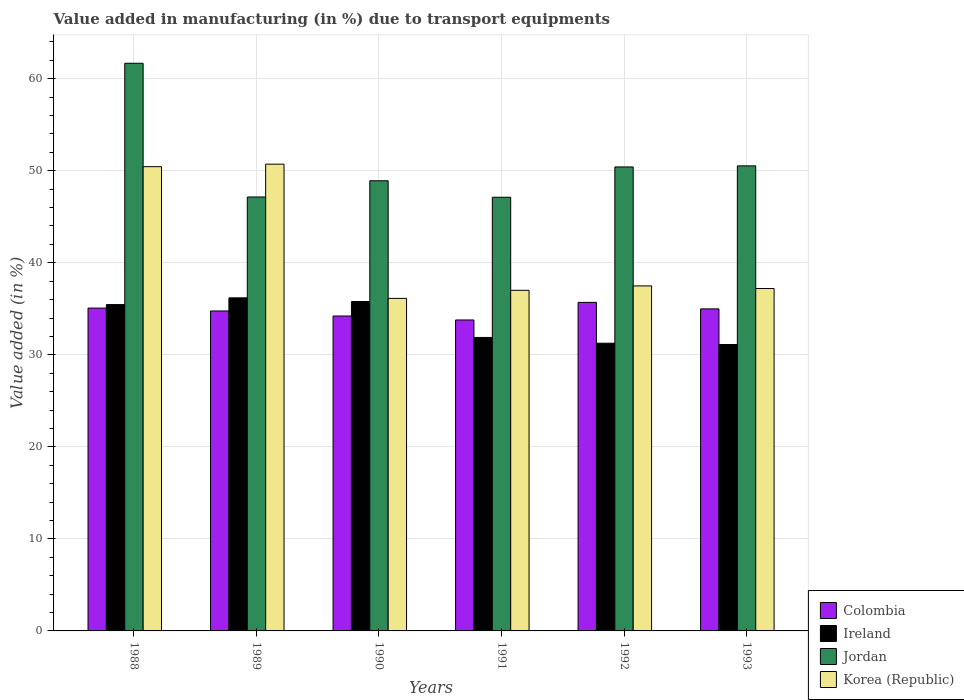How many groups of bars are there?
Provide a succinct answer. 6. Are the number of bars per tick equal to the number of legend labels?
Offer a terse response. Yes. How many bars are there on the 5th tick from the right?
Give a very brief answer. 4. What is the percentage of value added in manufacturing due to transport equipments in Ireland in 1988?
Keep it short and to the point. 35.46. Across all years, what is the maximum percentage of value added in manufacturing due to transport equipments in Korea (Republic)?
Your answer should be compact. 50.72. Across all years, what is the minimum percentage of value added in manufacturing due to transport equipments in Korea (Republic)?
Offer a very short reply. 36.13. In which year was the percentage of value added in manufacturing due to transport equipments in Jordan maximum?
Ensure brevity in your answer.  1988. What is the total percentage of value added in manufacturing due to transport equipments in Jordan in the graph?
Offer a terse response. 305.82. What is the difference between the percentage of value added in manufacturing due to transport equipments in Ireland in 1989 and that in 1991?
Give a very brief answer. 4.3. What is the difference between the percentage of value added in manufacturing due to transport equipments in Korea (Republic) in 1988 and the percentage of value added in manufacturing due to transport equipments in Jordan in 1989?
Provide a short and direct response. 3.29. What is the average percentage of value added in manufacturing due to transport equipments in Jordan per year?
Provide a short and direct response. 50.97. In the year 1991, what is the difference between the percentage of value added in manufacturing due to transport equipments in Jordan and percentage of value added in manufacturing due to transport equipments in Ireland?
Your response must be concise. 15.24. What is the ratio of the percentage of value added in manufacturing due to transport equipments in Colombia in 1988 to that in 1991?
Offer a very short reply. 1.04. Is the difference between the percentage of value added in manufacturing due to transport equipments in Jordan in 1992 and 1993 greater than the difference between the percentage of value added in manufacturing due to transport equipments in Ireland in 1992 and 1993?
Give a very brief answer. No. What is the difference between the highest and the second highest percentage of value added in manufacturing due to transport equipments in Jordan?
Ensure brevity in your answer.  11.15. What is the difference between the highest and the lowest percentage of value added in manufacturing due to transport equipments in Korea (Republic)?
Your response must be concise. 14.59. Is the sum of the percentage of value added in manufacturing due to transport equipments in Korea (Republic) in 1988 and 1991 greater than the maximum percentage of value added in manufacturing due to transport equipments in Jordan across all years?
Keep it short and to the point. Yes. Is it the case that in every year, the sum of the percentage of value added in manufacturing due to transport equipments in Korea (Republic) and percentage of value added in manufacturing due to transport equipments in Ireland is greater than the sum of percentage of value added in manufacturing due to transport equipments in Colombia and percentage of value added in manufacturing due to transport equipments in Jordan?
Your answer should be compact. Yes. What does the 4th bar from the right in 1991 represents?
Offer a very short reply. Colombia. Is it the case that in every year, the sum of the percentage of value added in manufacturing due to transport equipments in Korea (Republic) and percentage of value added in manufacturing due to transport equipments in Ireland is greater than the percentage of value added in manufacturing due to transport equipments in Colombia?
Make the answer very short. Yes. Are all the bars in the graph horizontal?
Provide a short and direct response. No. Are the values on the major ticks of Y-axis written in scientific E-notation?
Provide a succinct answer. No. How many legend labels are there?
Provide a short and direct response. 4. How are the legend labels stacked?
Provide a short and direct response. Vertical. What is the title of the graph?
Your answer should be very brief. Value added in manufacturing (in %) due to transport equipments. Does "Ghana" appear as one of the legend labels in the graph?
Offer a very short reply. No. What is the label or title of the Y-axis?
Give a very brief answer. Value added (in %). What is the Value added (in %) in Colombia in 1988?
Keep it short and to the point. 35.08. What is the Value added (in %) of Ireland in 1988?
Keep it short and to the point. 35.46. What is the Value added (in %) in Jordan in 1988?
Your answer should be compact. 61.68. What is the Value added (in %) of Korea (Republic) in 1988?
Your response must be concise. 50.45. What is the Value added (in %) in Colombia in 1989?
Give a very brief answer. 34.77. What is the Value added (in %) in Ireland in 1989?
Offer a very short reply. 36.19. What is the Value added (in %) of Jordan in 1989?
Provide a short and direct response. 47.15. What is the Value added (in %) in Korea (Republic) in 1989?
Your response must be concise. 50.72. What is the Value added (in %) in Colombia in 1990?
Make the answer very short. 34.22. What is the Value added (in %) of Ireland in 1990?
Your response must be concise. 35.79. What is the Value added (in %) of Jordan in 1990?
Your response must be concise. 48.91. What is the Value added (in %) in Korea (Republic) in 1990?
Provide a short and direct response. 36.13. What is the Value added (in %) in Colombia in 1991?
Provide a succinct answer. 33.79. What is the Value added (in %) in Ireland in 1991?
Your response must be concise. 31.89. What is the Value added (in %) in Jordan in 1991?
Your response must be concise. 47.12. What is the Value added (in %) in Korea (Republic) in 1991?
Offer a terse response. 37.01. What is the Value added (in %) in Colombia in 1992?
Your answer should be very brief. 35.7. What is the Value added (in %) in Ireland in 1992?
Make the answer very short. 31.26. What is the Value added (in %) of Jordan in 1992?
Offer a terse response. 50.42. What is the Value added (in %) of Korea (Republic) in 1992?
Keep it short and to the point. 37.49. What is the Value added (in %) in Colombia in 1993?
Give a very brief answer. 34.99. What is the Value added (in %) of Ireland in 1993?
Your answer should be very brief. 31.12. What is the Value added (in %) in Jordan in 1993?
Your answer should be very brief. 50.53. What is the Value added (in %) of Korea (Republic) in 1993?
Offer a terse response. 37.21. Across all years, what is the maximum Value added (in %) of Colombia?
Ensure brevity in your answer.  35.7. Across all years, what is the maximum Value added (in %) of Ireland?
Make the answer very short. 36.19. Across all years, what is the maximum Value added (in %) of Jordan?
Give a very brief answer. 61.68. Across all years, what is the maximum Value added (in %) of Korea (Republic)?
Your answer should be very brief. 50.72. Across all years, what is the minimum Value added (in %) in Colombia?
Your response must be concise. 33.79. Across all years, what is the minimum Value added (in %) of Ireland?
Give a very brief answer. 31.12. Across all years, what is the minimum Value added (in %) in Jordan?
Make the answer very short. 47.12. Across all years, what is the minimum Value added (in %) of Korea (Republic)?
Your answer should be very brief. 36.13. What is the total Value added (in %) of Colombia in the graph?
Offer a terse response. 208.54. What is the total Value added (in %) in Ireland in the graph?
Your response must be concise. 201.72. What is the total Value added (in %) in Jordan in the graph?
Give a very brief answer. 305.82. What is the total Value added (in %) of Korea (Republic) in the graph?
Your answer should be compact. 249. What is the difference between the Value added (in %) in Colombia in 1988 and that in 1989?
Ensure brevity in your answer.  0.31. What is the difference between the Value added (in %) in Ireland in 1988 and that in 1989?
Your answer should be very brief. -0.73. What is the difference between the Value added (in %) of Jordan in 1988 and that in 1989?
Ensure brevity in your answer.  14.53. What is the difference between the Value added (in %) in Korea (Republic) in 1988 and that in 1989?
Make the answer very short. -0.27. What is the difference between the Value added (in %) of Colombia in 1988 and that in 1990?
Offer a terse response. 0.86. What is the difference between the Value added (in %) of Ireland in 1988 and that in 1990?
Ensure brevity in your answer.  -0.33. What is the difference between the Value added (in %) of Jordan in 1988 and that in 1990?
Your response must be concise. 12.77. What is the difference between the Value added (in %) in Korea (Republic) in 1988 and that in 1990?
Keep it short and to the point. 14.31. What is the difference between the Value added (in %) in Colombia in 1988 and that in 1991?
Offer a very short reply. 1.29. What is the difference between the Value added (in %) in Ireland in 1988 and that in 1991?
Provide a succinct answer. 3.57. What is the difference between the Value added (in %) in Jordan in 1988 and that in 1991?
Give a very brief answer. 14.56. What is the difference between the Value added (in %) of Korea (Republic) in 1988 and that in 1991?
Offer a very short reply. 13.43. What is the difference between the Value added (in %) of Colombia in 1988 and that in 1992?
Your answer should be compact. -0.62. What is the difference between the Value added (in %) in Ireland in 1988 and that in 1992?
Ensure brevity in your answer.  4.2. What is the difference between the Value added (in %) in Jordan in 1988 and that in 1992?
Ensure brevity in your answer.  11.27. What is the difference between the Value added (in %) in Korea (Republic) in 1988 and that in 1992?
Your answer should be very brief. 12.96. What is the difference between the Value added (in %) in Colombia in 1988 and that in 1993?
Ensure brevity in your answer.  0.09. What is the difference between the Value added (in %) in Ireland in 1988 and that in 1993?
Provide a short and direct response. 4.34. What is the difference between the Value added (in %) in Jordan in 1988 and that in 1993?
Make the answer very short. 11.15. What is the difference between the Value added (in %) of Korea (Republic) in 1988 and that in 1993?
Provide a succinct answer. 13.24. What is the difference between the Value added (in %) of Colombia in 1989 and that in 1990?
Give a very brief answer. 0.55. What is the difference between the Value added (in %) of Ireland in 1989 and that in 1990?
Make the answer very short. 0.4. What is the difference between the Value added (in %) of Jordan in 1989 and that in 1990?
Your answer should be compact. -1.76. What is the difference between the Value added (in %) in Korea (Republic) in 1989 and that in 1990?
Offer a terse response. 14.59. What is the difference between the Value added (in %) of Colombia in 1989 and that in 1991?
Offer a terse response. 0.98. What is the difference between the Value added (in %) in Ireland in 1989 and that in 1991?
Provide a succinct answer. 4.3. What is the difference between the Value added (in %) in Jordan in 1989 and that in 1991?
Ensure brevity in your answer.  0.03. What is the difference between the Value added (in %) in Korea (Republic) in 1989 and that in 1991?
Keep it short and to the point. 13.71. What is the difference between the Value added (in %) in Colombia in 1989 and that in 1992?
Offer a terse response. -0.93. What is the difference between the Value added (in %) in Ireland in 1989 and that in 1992?
Provide a short and direct response. 4.93. What is the difference between the Value added (in %) of Jordan in 1989 and that in 1992?
Your answer should be compact. -3.26. What is the difference between the Value added (in %) of Korea (Republic) in 1989 and that in 1992?
Offer a very short reply. 13.23. What is the difference between the Value added (in %) of Colombia in 1989 and that in 1993?
Ensure brevity in your answer.  -0.23. What is the difference between the Value added (in %) in Ireland in 1989 and that in 1993?
Make the answer very short. 5.07. What is the difference between the Value added (in %) of Jordan in 1989 and that in 1993?
Give a very brief answer. -3.38. What is the difference between the Value added (in %) in Korea (Republic) in 1989 and that in 1993?
Your response must be concise. 13.51. What is the difference between the Value added (in %) of Colombia in 1990 and that in 1991?
Your answer should be very brief. 0.43. What is the difference between the Value added (in %) in Ireland in 1990 and that in 1991?
Provide a short and direct response. 3.9. What is the difference between the Value added (in %) in Jordan in 1990 and that in 1991?
Your response must be concise. 1.79. What is the difference between the Value added (in %) of Korea (Republic) in 1990 and that in 1991?
Provide a succinct answer. -0.88. What is the difference between the Value added (in %) of Colombia in 1990 and that in 1992?
Make the answer very short. -1.48. What is the difference between the Value added (in %) in Ireland in 1990 and that in 1992?
Your answer should be compact. 4.53. What is the difference between the Value added (in %) in Jordan in 1990 and that in 1992?
Provide a short and direct response. -1.5. What is the difference between the Value added (in %) in Korea (Republic) in 1990 and that in 1992?
Your response must be concise. -1.35. What is the difference between the Value added (in %) in Colombia in 1990 and that in 1993?
Ensure brevity in your answer.  -0.77. What is the difference between the Value added (in %) in Ireland in 1990 and that in 1993?
Offer a very short reply. 4.67. What is the difference between the Value added (in %) of Jordan in 1990 and that in 1993?
Provide a short and direct response. -1.62. What is the difference between the Value added (in %) in Korea (Republic) in 1990 and that in 1993?
Provide a short and direct response. -1.07. What is the difference between the Value added (in %) in Colombia in 1991 and that in 1992?
Provide a short and direct response. -1.91. What is the difference between the Value added (in %) in Ireland in 1991 and that in 1992?
Make the answer very short. 0.62. What is the difference between the Value added (in %) of Jordan in 1991 and that in 1992?
Your response must be concise. -3.29. What is the difference between the Value added (in %) of Korea (Republic) in 1991 and that in 1992?
Make the answer very short. -0.48. What is the difference between the Value added (in %) of Colombia in 1991 and that in 1993?
Ensure brevity in your answer.  -1.2. What is the difference between the Value added (in %) of Ireland in 1991 and that in 1993?
Offer a very short reply. 0.77. What is the difference between the Value added (in %) of Jordan in 1991 and that in 1993?
Offer a very short reply. -3.41. What is the difference between the Value added (in %) of Korea (Republic) in 1991 and that in 1993?
Provide a short and direct response. -0.19. What is the difference between the Value added (in %) in Colombia in 1992 and that in 1993?
Your response must be concise. 0.71. What is the difference between the Value added (in %) in Ireland in 1992 and that in 1993?
Provide a succinct answer. 0.14. What is the difference between the Value added (in %) in Jordan in 1992 and that in 1993?
Keep it short and to the point. -0.12. What is the difference between the Value added (in %) in Korea (Republic) in 1992 and that in 1993?
Ensure brevity in your answer.  0.28. What is the difference between the Value added (in %) of Colombia in 1988 and the Value added (in %) of Ireland in 1989?
Keep it short and to the point. -1.11. What is the difference between the Value added (in %) in Colombia in 1988 and the Value added (in %) in Jordan in 1989?
Your answer should be very brief. -12.07. What is the difference between the Value added (in %) of Colombia in 1988 and the Value added (in %) of Korea (Republic) in 1989?
Offer a very short reply. -15.64. What is the difference between the Value added (in %) of Ireland in 1988 and the Value added (in %) of Jordan in 1989?
Your answer should be compact. -11.69. What is the difference between the Value added (in %) of Ireland in 1988 and the Value added (in %) of Korea (Republic) in 1989?
Your answer should be compact. -15.26. What is the difference between the Value added (in %) in Jordan in 1988 and the Value added (in %) in Korea (Republic) in 1989?
Offer a very short reply. 10.96. What is the difference between the Value added (in %) in Colombia in 1988 and the Value added (in %) in Ireland in 1990?
Your answer should be very brief. -0.71. What is the difference between the Value added (in %) in Colombia in 1988 and the Value added (in %) in Jordan in 1990?
Offer a terse response. -13.84. What is the difference between the Value added (in %) of Colombia in 1988 and the Value added (in %) of Korea (Republic) in 1990?
Your answer should be very brief. -1.05. What is the difference between the Value added (in %) of Ireland in 1988 and the Value added (in %) of Jordan in 1990?
Offer a very short reply. -13.45. What is the difference between the Value added (in %) in Ireland in 1988 and the Value added (in %) in Korea (Republic) in 1990?
Provide a succinct answer. -0.67. What is the difference between the Value added (in %) in Jordan in 1988 and the Value added (in %) in Korea (Republic) in 1990?
Provide a short and direct response. 25.55. What is the difference between the Value added (in %) of Colombia in 1988 and the Value added (in %) of Ireland in 1991?
Make the answer very short. 3.19. What is the difference between the Value added (in %) of Colombia in 1988 and the Value added (in %) of Jordan in 1991?
Your answer should be very brief. -12.05. What is the difference between the Value added (in %) of Colombia in 1988 and the Value added (in %) of Korea (Republic) in 1991?
Give a very brief answer. -1.93. What is the difference between the Value added (in %) of Ireland in 1988 and the Value added (in %) of Jordan in 1991?
Provide a succinct answer. -11.66. What is the difference between the Value added (in %) of Ireland in 1988 and the Value added (in %) of Korea (Republic) in 1991?
Keep it short and to the point. -1.55. What is the difference between the Value added (in %) of Jordan in 1988 and the Value added (in %) of Korea (Republic) in 1991?
Offer a very short reply. 24.67. What is the difference between the Value added (in %) in Colombia in 1988 and the Value added (in %) in Ireland in 1992?
Offer a terse response. 3.81. What is the difference between the Value added (in %) in Colombia in 1988 and the Value added (in %) in Jordan in 1992?
Provide a succinct answer. -15.34. What is the difference between the Value added (in %) of Colombia in 1988 and the Value added (in %) of Korea (Republic) in 1992?
Make the answer very short. -2.41. What is the difference between the Value added (in %) in Ireland in 1988 and the Value added (in %) in Jordan in 1992?
Provide a short and direct response. -14.96. What is the difference between the Value added (in %) in Ireland in 1988 and the Value added (in %) in Korea (Republic) in 1992?
Offer a terse response. -2.03. What is the difference between the Value added (in %) of Jordan in 1988 and the Value added (in %) of Korea (Republic) in 1992?
Your answer should be very brief. 24.19. What is the difference between the Value added (in %) of Colombia in 1988 and the Value added (in %) of Ireland in 1993?
Your answer should be compact. 3.96. What is the difference between the Value added (in %) in Colombia in 1988 and the Value added (in %) in Jordan in 1993?
Keep it short and to the point. -15.46. What is the difference between the Value added (in %) of Colombia in 1988 and the Value added (in %) of Korea (Republic) in 1993?
Provide a succinct answer. -2.13. What is the difference between the Value added (in %) of Ireland in 1988 and the Value added (in %) of Jordan in 1993?
Make the answer very short. -15.07. What is the difference between the Value added (in %) of Ireland in 1988 and the Value added (in %) of Korea (Republic) in 1993?
Give a very brief answer. -1.74. What is the difference between the Value added (in %) of Jordan in 1988 and the Value added (in %) of Korea (Republic) in 1993?
Your answer should be compact. 24.48. What is the difference between the Value added (in %) of Colombia in 1989 and the Value added (in %) of Ireland in 1990?
Offer a very short reply. -1.03. What is the difference between the Value added (in %) of Colombia in 1989 and the Value added (in %) of Jordan in 1990?
Give a very brief answer. -14.15. What is the difference between the Value added (in %) in Colombia in 1989 and the Value added (in %) in Korea (Republic) in 1990?
Keep it short and to the point. -1.37. What is the difference between the Value added (in %) in Ireland in 1989 and the Value added (in %) in Jordan in 1990?
Ensure brevity in your answer.  -12.72. What is the difference between the Value added (in %) in Ireland in 1989 and the Value added (in %) in Korea (Republic) in 1990?
Ensure brevity in your answer.  0.06. What is the difference between the Value added (in %) of Jordan in 1989 and the Value added (in %) of Korea (Republic) in 1990?
Give a very brief answer. 11.02. What is the difference between the Value added (in %) in Colombia in 1989 and the Value added (in %) in Ireland in 1991?
Your response must be concise. 2.88. What is the difference between the Value added (in %) of Colombia in 1989 and the Value added (in %) of Jordan in 1991?
Offer a very short reply. -12.36. What is the difference between the Value added (in %) in Colombia in 1989 and the Value added (in %) in Korea (Republic) in 1991?
Provide a short and direct response. -2.24. What is the difference between the Value added (in %) of Ireland in 1989 and the Value added (in %) of Jordan in 1991?
Make the answer very short. -10.93. What is the difference between the Value added (in %) in Ireland in 1989 and the Value added (in %) in Korea (Republic) in 1991?
Offer a terse response. -0.82. What is the difference between the Value added (in %) in Jordan in 1989 and the Value added (in %) in Korea (Republic) in 1991?
Offer a very short reply. 10.14. What is the difference between the Value added (in %) in Colombia in 1989 and the Value added (in %) in Ireland in 1992?
Keep it short and to the point. 3.5. What is the difference between the Value added (in %) of Colombia in 1989 and the Value added (in %) of Jordan in 1992?
Make the answer very short. -15.65. What is the difference between the Value added (in %) of Colombia in 1989 and the Value added (in %) of Korea (Republic) in 1992?
Your answer should be compact. -2.72. What is the difference between the Value added (in %) in Ireland in 1989 and the Value added (in %) in Jordan in 1992?
Offer a terse response. -14.22. What is the difference between the Value added (in %) in Ireland in 1989 and the Value added (in %) in Korea (Republic) in 1992?
Give a very brief answer. -1.3. What is the difference between the Value added (in %) of Jordan in 1989 and the Value added (in %) of Korea (Republic) in 1992?
Your response must be concise. 9.66. What is the difference between the Value added (in %) in Colombia in 1989 and the Value added (in %) in Ireland in 1993?
Offer a terse response. 3.65. What is the difference between the Value added (in %) in Colombia in 1989 and the Value added (in %) in Jordan in 1993?
Keep it short and to the point. -15.77. What is the difference between the Value added (in %) in Colombia in 1989 and the Value added (in %) in Korea (Republic) in 1993?
Keep it short and to the point. -2.44. What is the difference between the Value added (in %) in Ireland in 1989 and the Value added (in %) in Jordan in 1993?
Keep it short and to the point. -14.34. What is the difference between the Value added (in %) in Ireland in 1989 and the Value added (in %) in Korea (Republic) in 1993?
Your answer should be very brief. -1.01. What is the difference between the Value added (in %) in Jordan in 1989 and the Value added (in %) in Korea (Republic) in 1993?
Provide a short and direct response. 9.95. What is the difference between the Value added (in %) in Colombia in 1990 and the Value added (in %) in Ireland in 1991?
Ensure brevity in your answer.  2.33. What is the difference between the Value added (in %) of Colombia in 1990 and the Value added (in %) of Jordan in 1991?
Give a very brief answer. -12.91. What is the difference between the Value added (in %) in Colombia in 1990 and the Value added (in %) in Korea (Republic) in 1991?
Your answer should be compact. -2.79. What is the difference between the Value added (in %) in Ireland in 1990 and the Value added (in %) in Jordan in 1991?
Your answer should be very brief. -11.33. What is the difference between the Value added (in %) of Ireland in 1990 and the Value added (in %) of Korea (Republic) in 1991?
Keep it short and to the point. -1.22. What is the difference between the Value added (in %) of Jordan in 1990 and the Value added (in %) of Korea (Republic) in 1991?
Ensure brevity in your answer.  11.9. What is the difference between the Value added (in %) of Colombia in 1990 and the Value added (in %) of Ireland in 1992?
Give a very brief answer. 2.95. What is the difference between the Value added (in %) of Colombia in 1990 and the Value added (in %) of Jordan in 1992?
Offer a terse response. -16.2. What is the difference between the Value added (in %) of Colombia in 1990 and the Value added (in %) of Korea (Republic) in 1992?
Keep it short and to the point. -3.27. What is the difference between the Value added (in %) in Ireland in 1990 and the Value added (in %) in Jordan in 1992?
Ensure brevity in your answer.  -14.62. What is the difference between the Value added (in %) in Ireland in 1990 and the Value added (in %) in Korea (Republic) in 1992?
Your response must be concise. -1.7. What is the difference between the Value added (in %) in Jordan in 1990 and the Value added (in %) in Korea (Republic) in 1992?
Provide a succinct answer. 11.43. What is the difference between the Value added (in %) in Colombia in 1990 and the Value added (in %) in Ireland in 1993?
Offer a terse response. 3.1. What is the difference between the Value added (in %) in Colombia in 1990 and the Value added (in %) in Jordan in 1993?
Offer a terse response. -16.32. What is the difference between the Value added (in %) of Colombia in 1990 and the Value added (in %) of Korea (Republic) in 1993?
Offer a very short reply. -2.99. What is the difference between the Value added (in %) in Ireland in 1990 and the Value added (in %) in Jordan in 1993?
Your answer should be compact. -14.74. What is the difference between the Value added (in %) of Ireland in 1990 and the Value added (in %) of Korea (Republic) in 1993?
Make the answer very short. -1.41. What is the difference between the Value added (in %) of Jordan in 1990 and the Value added (in %) of Korea (Republic) in 1993?
Provide a short and direct response. 11.71. What is the difference between the Value added (in %) in Colombia in 1991 and the Value added (in %) in Ireland in 1992?
Ensure brevity in your answer.  2.52. What is the difference between the Value added (in %) in Colombia in 1991 and the Value added (in %) in Jordan in 1992?
Your response must be concise. -16.63. What is the difference between the Value added (in %) of Colombia in 1991 and the Value added (in %) of Korea (Republic) in 1992?
Your response must be concise. -3.7. What is the difference between the Value added (in %) of Ireland in 1991 and the Value added (in %) of Jordan in 1992?
Provide a short and direct response. -18.53. What is the difference between the Value added (in %) in Ireland in 1991 and the Value added (in %) in Korea (Republic) in 1992?
Your response must be concise. -5.6. What is the difference between the Value added (in %) in Jordan in 1991 and the Value added (in %) in Korea (Republic) in 1992?
Provide a succinct answer. 9.64. What is the difference between the Value added (in %) of Colombia in 1991 and the Value added (in %) of Ireland in 1993?
Your answer should be very brief. 2.67. What is the difference between the Value added (in %) in Colombia in 1991 and the Value added (in %) in Jordan in 1993?
Ensure brevity in your answer.  -16.74. What is the difference between the Value added (in %) of Colombia in 1991 and the Value added (in %) of Korea (Republic) in 1993?
Keep it short and to the point. -3.42. What is the difference between the Value added (in %) of Ireland in 1991 and the Value added (in %) of Jordan in 1993?
Keep it short and to the point. -18.64. What is the difference between the Value added (in %) of Ireland in 1991 and the Value added (in %) of Korea (Republic) in 1993?
Keep it short and to the point. -5.32. What is the difference between the Value added (in %) in Jordan in 1991 and the Value added (in %) in Korea (Republic) in 1993?
Provide a short and direct response. 9.92. What is the difference between the Value added (in %) in Colombia in 1992 and the Value added (in %) in Ireland in 1993?
Offer a terse response. 4.58. What is the difference between the Value added (in %) of Colombia in 1992 and the Value added (in %) of Jordan in 1993?
Give a very brief answer. -14.83. What is the difference between the Value added (in %) in Colombia in 1992 and the Value added (in %) in Korea (Republic) in 1993?
Provide a succinct answer. -1.51. What is the difference between the Value added (in %) in Ireland in 1992 and the Value added (in %) in Jordan in 1993?
Your answer should be compact. -19.27. What is the difference between the Value added (in %) in Ireland in 1992 and the Value added (in %) in Korea (Republic) in 1993?
Provide a succinct answer. -5.94. What is the difference between the Value added (in %) in Jordan in 1992 and the Value added (in %) in Korea (Republic) in 1993?
Your response must be concise. 13.21. What is the average Value added (in %) of Colombia per year?
Your response must be concise. 34.76. What is the average Value added (in %) in Ireland per year?
Provide a succinct answer. 33.62. What is the average Value added (in %) in Jordan per year?
Make the answer very short. 50.97. What is the average Value added (in %) in Korea (Republic) per year?
Your response must be concise. 41.5. In the year 1988, what is the difference between the Value added (in %) of Colombia and Value added (in %) of Ireland?
Make the answer very short. -0.38. In the year 1988, what is the difference between the Value added (in %) of Colombia and Value added (in %) of Jordan?
Your response must be concise. -26.6. In the year 1988, what is the difference between the Value added (in %) of Colombia and Value added (in %) of Korea (Republic)?
Your answer should be very brief. -15.37. In the year 1988, what is the difference between the Value added (in %) in Ireland and Value added (in %) in Jordan?
Ensure brevity in your answer.  -26.22. In the year 1988, what is the difference between the Value added (in %) of Ireland and Value added (in %) of Korea (Republic)?
Offer a very short reply. -14.99. In the year 1988, what is the difference between the Value added (in %) in Jordan and Value added (in %) in Korea (Republic)?
Make the answer very short. 11.24. In the year 1989, what is the difference between the Value added (in %) of Colombia and Value added (in %) of Ireland?
Your answer should be compact. -1.43. In the year 1989, what is the difference between the Value added (in %) of Colombia and Value added (in %) of Jordan?
Your answer should be compact. -12.39. In the year 1989, what is the difference between the Value added (in %) of Colombia and Value added (in %) of Korea (Republic)?
Offer a terse response. -15.95. In the year 1989, what is the difference between the Value added (in %) of Ireland and Value added (in %) of Jordan?
Make the answer very short. -10.96. In the year 1989, what is the difference between the Value added (in %) of Ireland and Value added (in %) of Korea (Republic)?
Ensure brevity in your answer.  -14.53. In the year 1989, what is the difference between the Value added (in %) of Jordan and Value added (in %) of Korea (Republic)?
Ensure brevity in your answer.  -3.57. In the year 1990, what is the difference between the Value added (in %) of Colombia and Value added (in %) of Ireland?
Your response must be concise. -1.57. In the year 1990, what is the difference between the Value added (in %) of Colombia and Value added (in %) of Jordan?
Keep it short and to the point. -14.7. In the year 1990, what is the difference between the Value added (in %) in Colombia and Value added (in %) in Korea (Republic)?
Provide a succinct answer. -1.91. In the year 1990, what is the difference between the Value added (in %) of Ireland and Value added (in %) of Jordan?
Offer a terse response. -13.12. In the year 1990, what is the difference between the Value added (in %) of Ireland and Value added (in %) of Korea (Republic)?
Your answer should be compact. -0.34. In the year 1990, what is the difference between the Value added (in %) of Jordan and Value added (in %) of Korea (Republic)?
Ensure brevity in your answer.  12.78. In the year 1991, what is the difference between the Value added (in %) of Colombia and Value added (in %) of Ireland?
Ensure brevity in your answer.  1.9. In the year 1991, what is the difference between the Value added (in %) in Colombia and Value added (in %) in Jordan?
Offer a very short reply. -13.34. In the year 1991, what is the difference between the Value added (in %) in Colombia and Value added (in %) in Korea (Republic)?
Provide a succinct answer. -3.22. In the year 1991, what is the difference between the Value added (in %) in Ireland and Value added (in %) in Jordan?
Make the answer very short. -15.24. In the year 1991, what is the difference between the Value added (in %) in Ireland and Value added (in %) in Korea (Republic)?
Provide a short and direct response. -5.12. In the year 1991, what is the difference between the Value added (in %) of Jordan and Value added (in %) of Korea (Republic)?
Your answer should be compact. 10.11. In the year 1992, what is the difference between the Value added (in %) of Colombia and Value added (in %) of Ireland?
Ensure brevity in your answer.  4.44. In the year 1992, what is the difference between the Value added (in %) of Colombia and Value added (in %) of Jordan?
Provide a short and direct response. -14.72. In the year 1992, what is the difference between the Value added (in %) of Colombia and Value added (in %) of Korea (Republic)?
Your response must be concise. -1.79. In the year 1992, what is the difference between the Value added (in %) in Ireland and Value added (in %) in Jordan?
Keep it short and to the point. -19.15. In the year 1992, what is the difference between the Value added (in %) of Ireland and Value added (in %) of Korea (Republic)?
Offer a very short reply. -6.22. In the year 1992, what is the difference between the Value added (in %) of Jordan and Value added (in %) of Korea (Republic)?
Offer a terse response. 12.93. In the year 1993, what is the difference between the Value added (in %) of Colombia and Value added (in %) of Ireland?
Your answer should be compact. 3.87. In the year 1993, what is the difference between the Value added (in %) of Colombia and Value added (in %) of Jordan?
Keep it short and to the point. -15.54. In the year 1993, what is the difference between the Value added (in %) in Colombia and Value added (in %) in Korea (Republic)?
Provide a succinct answer. -2.21. In the year 1993, what is the difference between the Value added (in %) in Ireland and Value added (in %) in Jordan?
Offer a terse response. -19.41. In the year 1993, what is the difference between the Value added (in %) in Ireland and Value added (in %) in Korea (Republic)?
Give a very brief answer. -6.08. In the year 1993, what is the difference between the Value added (in %) of Jordan and Value added (in %) of Korea (Republic)?
Give a very brief answer. 13.33. What is the ratio of the Value added (in %) in Colombia in 1988 to that in 1989?
Your response must be concise. 1.01. What is the ratio of the Value added (in %) in Ireland in 1988 to that in 1989?
Offer a very short reply. 0.98. What is the ratio of the Value added (in %) of Jordan in 1988 to that in 1989?
Give a very brief answer. 1.31. What is the ratio of the Value added (in %) of Korea (Republic) in 1988 to that in 1989?
Keep it short and to the point. 0.99. What is the ratio of the Value added (in %) in Colombia in 1988 to that in 1990?
Your response must be concise. 1.03. What is the ratio of the Value added (in %) in Ireland in 1988 to that in 1990?
Make the answer very short. 0.99. What is the ratio of the Value added (in %) in Jordan in 1988 to that in 1990?
Ensure brevity in your answer.  1.26. What is the ratio of the Value added (in %) of Korea (Republic) in 1988 to that in 1990?
Make the answer very short. 1.4. What is the ratio of the Value added (in %) of Colombia in 1988 to that in 1991?
Ensure brevity in your answer.  1.04. What is the ratio of the Value added (in %) in Ireland in 1988 to that in 1991?
Your response must be concise. 1.11. What is the ratio of the Value added (in %) of Jordan in 1988 to that in 1991?
Ensure brevity in your answer.  1.31. What is the ratio of the Value added (in %) in Korea (Republic) in 1988 to that in 1991?
Ensure brevity in your answer.  1.36. What is the ratio of the Value added (in %) of Colombia in 1988 to that in 1992?
Make the answer very short. 0.98. What is the ratio of the Value added (in %) in Ireland in 1988 to that in 1992?
Your response must be concise. 1.13. What is the ratio of the Value added (in %) in Jordan in 1988 to that in 1992?
Provide a short and direct response. 1.22. What is the ratio of the Value added (in %) in Korea (Republic) in 1988 to that in 1992?
Your answer should be compact. 1.35. What is the ratio of the Value added (in %) in Colombia in 1988 to that in 1993?
Your response must be concise. 1. What is the ratio of the Value added (in %) in Ireland in 1988 to that in 1993?
Offer a terse response. 1.14. What is the ratio of the Value added (in %) of Jordan in 1988 to that in 1993?
Provide a succinct answer. 1.22. What is the ratio of the Value added (in %) in Korea (Republic) in 1988 to that in 1993?
Offer a terse response. 1.36. What is the ratio of the Value added (in %) in Ireland in 1989 to that in 1990?
Ensure brevity in your answer.  1.01. What is the ratio of the Value added (in %) of Korea (Republic) in 1989 to that in 1990?
Your response must be concise. 1.4. What is the ratio of the Value added (in %) of Colombia in 1989 to that in 1991?
Your answer should be very brief. 1.03. What is the ratio of the Value added (in %) in Ireland in 1989 to that in 1991?
Ensure brevity in your answer.  1.14. What is the ratio of the Value added (in %) in Jordan in 1989 to that in 1991?
Give a very brief answer. 1. What is the ratio of the Value added (in %) of Korea (Republic) in 1989 to that in 1991?
Make the answer very short. 1.37. What is the ratio of the Value added (in %) in Colombia in 1989 to that in 1992?
Provide a short and direct response. 0.97. What is the ratio of the Value added (in %) of Ireland in 1989 to that in 1992?
Offer a very short reply. 1.16. What is the ratio of the Value added (in %) in Jordan in 1989 to that in 1992?
Provide a succinct answer. 0.94. What is the ratio of the Value added (in %) in Korea (Republic) in 1989 to that in 1992?
Provide a short and direct response. 1.35. What is the ratio of the Value added (in %) of Ireland in 1989 to that in 1993?
Your response must be concise. 1.16. What is the ratio of the Value added (in %) of Jordan in 1989 to that in 1993?
Offer a very short reply. 0.93. What is the ratio of the Value added (in %) in Korea (Republic) in 1989 to that in 1993?
Your response must be concise. 1.36. What is the ratio of the Value added (in %) of Colombia in 1990 to that in 1991?
Make the answer very short. 1.01. What is the ratio of the Value added (in %) in Ireland in 1990 to that in 1991?
Keep it short and to the point. 1.12. What is the ratio of the Value added (in %) of Jordan in 1990 to that in 1991?
Ensure brevity in your answer.  1.04. What is the ratio of the Value added (in %) of Korea (Republic) in 1990 to that in 1991?
Keep it short and to the point. 0.98. What is the ratio of the Value added (in %) in Colombia in 1990 to that in 1992?
Your response must be concise. 0.96. What is the ratio of the Value added (in %) in Ireland in 1990 to that in 1992?
Give a very brief answer. 1.14. What is the ratio of the Value added (in %) of Jordan in 1990 to that in 1992?
Provide a short and direct response. 0.97. What is the ratio of the Value added (in %) of Korea (Republic) in 1990 to that in 1992?
Your answer should be compact. 0.96. What is the ratio of the Value added (in %) of Colombia in 1990 to that in 1993?
Make the answer very short. 0.98. What is the ratio of the Value added (in %) of Ireland in 1990 to that in 1993?
Your answer should be very brief. 1.15. What is the ratio of the Value added (in %) of Jordan in 1990 to that in 1993?
Make the answer very short. 0.97. What is the ratio of the Value added (in %) of Korea (Republic) in 1990 to that in 1993?
Keep it short and to the point. 0.97. What is the ratio of the Value added (in %) in Colombia in 1991 to that in 1992?
Provide a succinct answer. 0.95. What is the ratio of the Value added (in %) of Ireland in 1991 to that in 1992?
Offer a terse response. 1.02. What is the ratio of the Value added (in %) in Jordan in 1991 to that in 1992?
Give a very brief answer. 0.93. What is the ratio of the Value added (in %) of Korea (Republic) in 1991 to that in 1992?
Provide a succinct answer. 0.99. What is the ratio of the Value added (in %) in Colombia in 1991 to that in 1993?
Offer a very short reply. 0.97. What is the ratio of the Value added (in %) in Ireland in 1991 to that in 1993?
Your answer should be very brief. 1.02. What is the ratio of the Value added (in %) in Jordan in 1991 to that in 1993?
Your answer should be very brief. 0.93. What is the ratio of the Value added (in %) of Korea (Republic) in 1991 to that in 1993?
Make the answer very short. 0.99. What is the ratio of the Value added (in %) of Colombia in 1992 to that in 1993?
Provide a succinct answer. 1.02. What is the ratio of the Value added (in %) of Korea (Republic) in 1992 to that in 1993?
Provide a succinct answer. 1.01. What is the difference between the highest and the second highest Value added (in %) in Colombia?
Your answer should be very brief. 0.62. What is the difference between the highest and the second highest Value added (in %) in Ireland?
Offer a terse response. 0.4. What is the difference between the highest and the second highest Value added (in %) in Jordan?
Your answer should be compact. 11.15. What is the difference between the highest and the second highest Value added (in %) of Korea (Republic)?
Ensure brevity in your answer.  0.27. What is the difference between the highest and the lowest Value added (in %) in Colombia?
Your answer should be compact. 1.91. What is the difference between the highest and the lowest Value added (in %) of Ireland?
Provide a short and direct response. 5.07. What is the difference between the highest and the lowest Value added (in %) of Jordan?
Provide a short and direct response. 14.56. What is the difference between the highest and the lowest Value added (in %) in Korea (Republic)?
Your response must be concise. 14.59. 